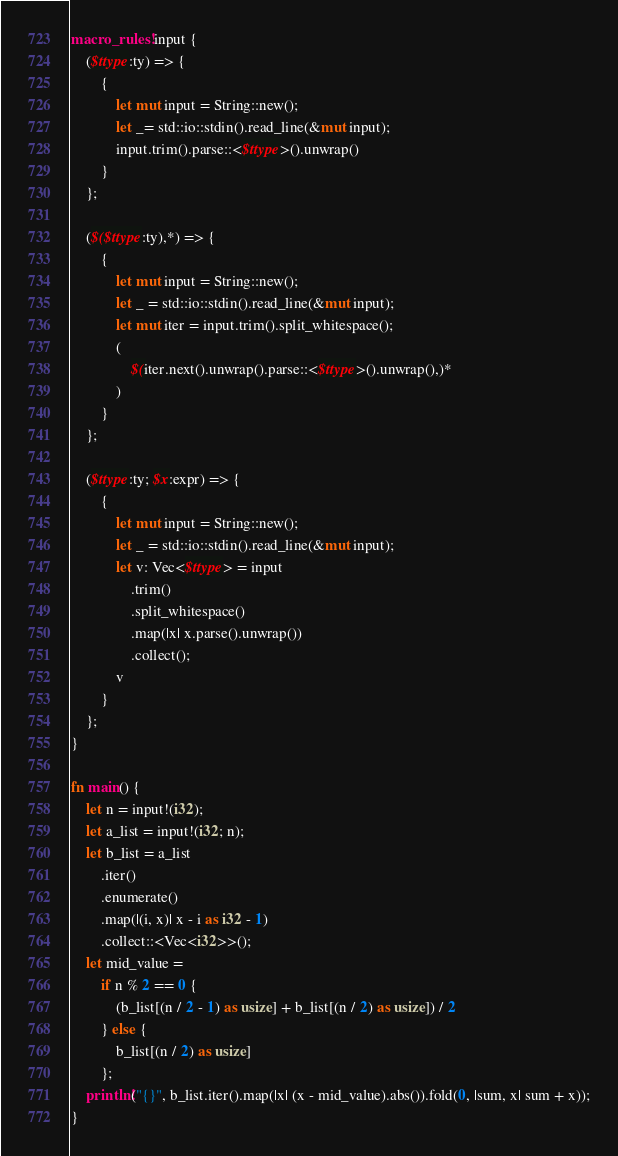Convert code to text. <code><loc_0><loc_0><loc_500><loc_500><_Rust_>macro_rules! input {
    ($ttype:ty) => {
        {
            let mut input = String::new();
            let _= std::io::stdin().read_line(&mut input);
            input.trim().parse::<$ttype>().unwrap()
        }
    };

    ($($ttype:ty),*) => {
        {
            let mut input = String::new();
            let _ = std::io::stdin().read_line(&mut input);
            let mut iter = input.trim().split_whitespace();
            (
                $(iter.next().unwrap().parse::<$ttype>().unwrap(),)*
            )
        }
    };

    ($ttype:ty; $x:expr) => {
        {
            let mut input = String::new();
            let _ = std::io::stdin().read_line(&mut input);
            let v: Vec<$ttype> = input
                .trim()
                .split_whitespace()
                .map(|x| x.parse().unwrap())
                .collect();
            v
        }
    };
}

fn main() {
    let n = input!(i32);
    let a_list = input!(i32; n);
    let b_list = a_list
        .iter()
        .enumerate()
        .map(|(i, x)| x - i as i32 - 1)
        .collect::<Vec<i32>>();
    let mid_value =
        if n % 2 == 0 {
            (b_list[(n / 2 - 1) as usize] + b_list[(n / 2) as usize]) / 2
        } else {
            b_list[(n / 2) as usize]
        };
    println!("{}", b_list.iter().map(|x| (x - mid_value).abs()).fold(0, |sum, x| sum + x));
}</code> 